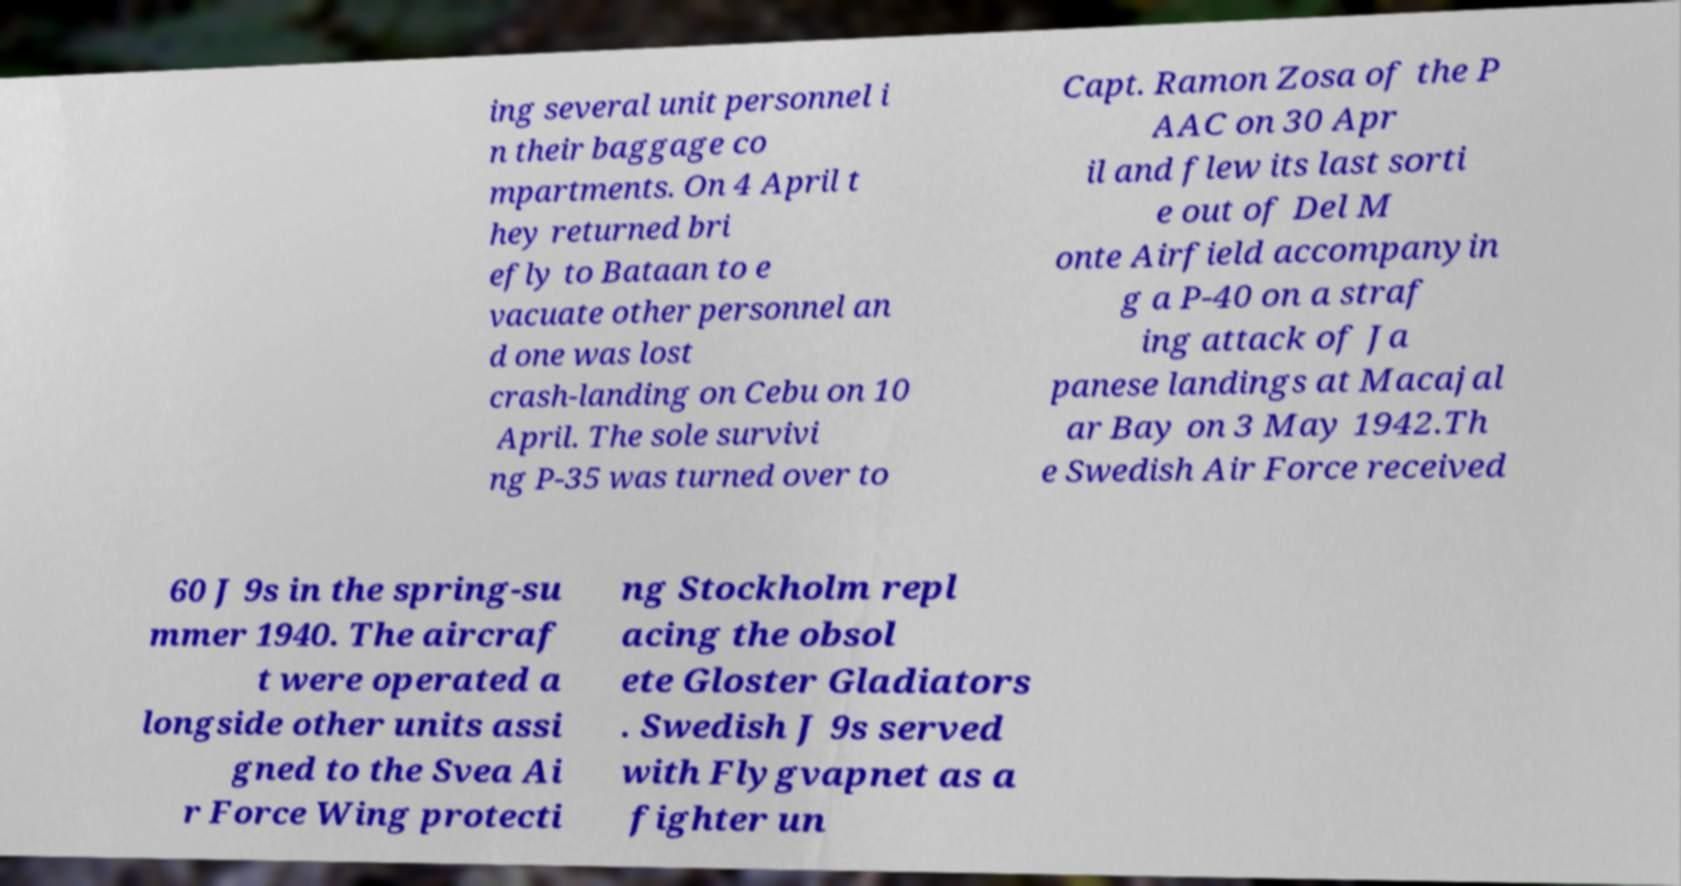There's text embedded in this image that I need extracted. Can you transcribe it verbatim? ing several unit personnel i n their baggage co mpartments. On 4 April t hey returned bri efly to Bataan to e vacuate other personnel an d one was lost crash-landing on Cebu on 10 April. The sole survivi ng P-35 was turned over to Capt. Ramon Zosa of the P AAC on 30 Apr il and flew its last sorti e out of Del M onte Airfield accompanyin g a P-40 on a straf ing attack of Ja panese landings at Macajal ar Bay on 3 May 1942.Th e Swedish Air Force received 60 J 9s in the spring-su mmer 1940. The aircraf t were operated a longside other units assi gned to the Svea Ai r Force Wing protecti ng Stockholm repl acing the obsol ete Gloster Gladiators . Swedish J 9s served with Flygvapnet as a fighter un 